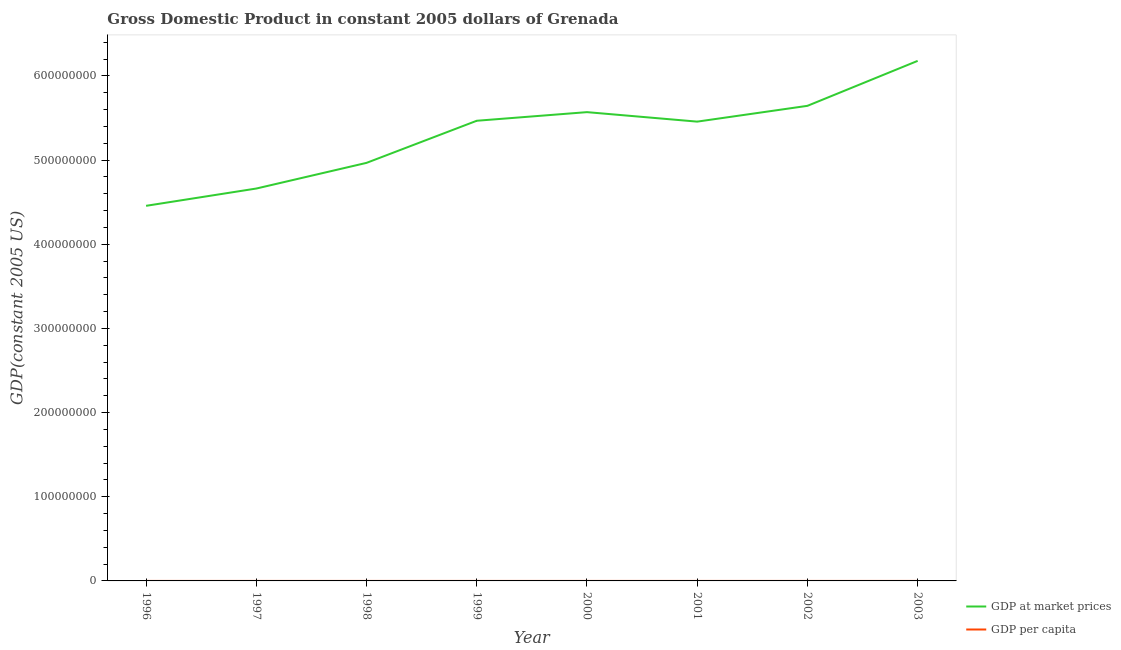What is the gdp per capita in 2000?
Your answer should be compact. 5481.04. Across all years, what is the maximum gdp at market prices?
Make the answer very short. 6.18e+08. Across all years, what is the minimum gdp per capita?
Ensure brevity in your answer.  4421.53. In which year was the gdp per capita minimum?
Keep it short and to the point. 1996. What is the total gdp per capita in the graph?
Ensure brevity in your answer.  4.17e+04. What is the difference between the gdp at market prices in 1998 and that in 1999?
Give a very brief answer. -5.00e+07. What is the difference between the gdp per capita in 2002 and the gdp at market prices in 1996?
Offer a very short reply. -4.46e+08. What is the average gdp at market prices per year?
Your response must be concise. 5.30e+08. In the year 1997, what is the difference between the gdp per capita and gdp at market prices?
Provide a succinct answer. -4.66e+08. What is the ratio of the gdp at market prices in 1996 to that in 2003?
Your response must be concise. 0.72. Is the gdp at market prices in 1998 less than that in 2001?
Your answer should be very brief. Yes. What is the difference between the highest and the second highest gdp at market prices?
Your answer should be very brief. 5.34e+07. What is the difference between the highest and the lowest gdp per capita?
Your answer should be compact. 1614.26. Is the sum of the gdp per capita in 1997 and 2003 greater than the maximum gdp at market prices across all years?
Your response must be concise. No. Does the gdp at market prices monotonically increase over the years?
Offer a very short reply. No. Is the gdp per capita strictly greater than the gdp at market prices over the years?
Offer a very short reply. No. How many lines are there?
Your answer should be very brief. 2. How many years are there in the graph?
Give a very brief answer. 8. Does the graph contain grids?
Provide a succinct answer. No. Where does the legend appear in the graph?
Provide a succinct answer. Bottom right. How many legend labels are there?
Provide a succinct answer. 2. How are the legend labels stacked?
Make the answer very short. Vertical. What is the title of the graph?
Provide a short and direct response. Gross Domestic Product in constant 2005 dollars of Grenada. What is the label or title of the X-axis?
Offer a terse response. Year. What is the label or title of the Y-axis?
Your response must be concise. GDP(constant 2005 US). What is the GDP(constant 2005 US) of GDP at market prices in 1996?
Give a very brief answer. 4.46e+08. What is the GDP(constant 2005 US) of GDP per capita in 1996?
Keep it short and to the point. 4421.53. What is the GDP(constant 2005 US) of GDP at market prices in 1997?
Your answer should be very brief. 4.66e+08. What is the GDP(constant 2005 US) of GDP per capita in 1997?
Your answer should be compact. 4610.26. What is the GDP(constant 2005 US) in GDP at market prices in 1998?
Your response must be concise. 4.97e+08. What is the GDP(constant 2005 US) in GDP per capita in 1998?
Your answer should be compact. 4903.28. What is the GDP(constant 2005 US) of GDP at market prices in 1999?
Give a very brief answer. 5.47e+08. What is the GDP(constant 2005 US) in GDP per capita in 1999?
Your response must be concise. 5389.76. What is the GDP(constant 2005 US) in GDP at market prices in 2000?
Give a very brief answer. 5.57e+08. What is the GDP(constant 2005 US) of GDP per capita in 2000?
Make the answer very short. 5481.04. What is the GDP(constant 2005 US) in GDP at market prices in 2001?
Ensure brevity in your answer.  5.46e+08. What is the GDP(constant 2005 US) in GDP per capita in 2001?
Offer a terse response. 5358.03. What is the GDP(constant 2005 US) in GDP at market prices in 2002?
Provide a succinct answer. 5.64e+08. What is the GDP(constant 2005 US) in GDP per capita in 2002?
Offer a terse response. 5528.58. What is the GDP(constant 2005 US) of GDP at market prices in 2003?
Provide a short and direct response. 6.18e+08. What is the GDP(constant 2005 US) of GDP per capita in 2003?
Your answer should be compact. 6035.78. Across all years, what is the maximum GDP(constant 2005 US) of GDP at market prices?
Provide a succinct answer. 6.18e+08. Across all years, what is the maximum GDP(constant 2005 US) of GDP per capita?
Ensure brevity in your answer.  6035.78. Across all years, what is the minimum GDP(constant 2005 US) of GDP at market prices?
Provide a short and direct response. 4.46e+08. Across all years, what is the minimum GDP(constant 2005 US) of GDP per capita?
Offer a terse response. 4421.53. What is the total GDP(constant 2005 US) in GDP at market prices in the graph?
Give a very brief answer. 4.24e+09. What is the total GDP(constant 2005 US) in GDP per capita in the graph?
Give a very brief answer. 4.17e+04. What is the difference between the GDP(constant 2005 US) of GDP at market prices in 1996 and that in 1997?
Offer a terse response. -2.05e+07. What is the difference between the GDP(constant 2005 US) in GDP per capita in 1996 and that in 1997?
Keep it short and to the point. -188.73. What is the difference between the GDP(constant 2005 US) in GDP at market prices in 1996 and that in 1998?
Offer a terse response. -5.10e+07. What is the difference between the GDP(constant 2005 US) in GDP per capita in 1996 and that in 1998?
Provide a succinct answer. -481.75. What is the difference between the GDP(constant 2005 US) of GDP at market prices in 1996 and that in 1999?
Offer a very short reply. -1.01e+08. What is the difference between the GDP(constant 2005 US) in GDP per capita in 1996 and that in 1999?
Offer a very short reply. -968.24. What is the difference between the GDP(constant 2005 US) of GDP at market prices in 1996 and that in 2000?
Your answer should be compact. -1.11e+08. What is the difference between the GDP(constant 2005 US) in GDP per capita in 1996 and that in 2000?
Make the answer very short. -1059.51. What is the difference between the GDP(constant 2005 US) of GDP at market prices in 1996 and that in 2001?
Your answer should be very brief. -1.00e+08. What is the difference between the GDP(constant 2005 US) of GDP per capita in 1996 and that in 2001?
Your answer should be compact. -936.51. What is the difference between the GDP(constant 2005 US) in GDP at market prices in 1996 and that in 2002?
Offer a very short reply. -1.19e+08. What is the difference between the GDP(constant 2005 US) in GDP per capita in 1996 and that in 2002?
Give a very brief answer. -1107.05. What is the difference between the GDP(constant 2005 US) in GDP at market prices in 1996 and that in 2003?
Provide a short and direct response. -1.72e+08. What is the difference between the GDP(constant 2005 US) of GDP per capita in 1996 and that in 2003?
Make the answer very short. -1614.26. What is the difference between the GDP(constant 2005 US) in GDP at market prices in 1997 and that in 1998?
Give a very brief answer. -3.05e+07. What is the difference between the GDP(constant 2005 US) in GDP per capita in 1997 and that in 1998?
Give a very brief answer. -293.02. What is the difference between the GDP(constant 2005 US) in GDP at market prices in 1997 and that in 1999?
Your response must be concise. -8.05e+07. What is the difference between the GDP(constant 2005 US) in GDP per capita in 1997 and that in 1999?
Offer a terse response. -779.5. What is the difference between the GDP(constant 2005 US) of GDP at market prices in 1997 and that in 2000?
Your answer should be compact. -9.08e+07. What is the difference between the GDP(constant 2005 US) of GDP per capita in 1997 and that in 2000?
Your response must be concise. -870.78. What is the difference between the GDP(constant 2005 US) of GDP at market prices in 1997 and that in 2001?
Ensure brevity in your answer.  -7.95e+07. What is the difference between the GDP(constant 2005 US) in GDP per capita in 1997 and that in 2001?
Your answer should be compact. -747.77. What is the difference between the GDP(constant 2005 US) of GDP at market prices in 1997 and that in 2002?
Ensure brevity in your answer.  -9.83e+07. What is the difference between the GDP(constant 2005 US) of GDP per capita in 1997 and that in 2002?
Make the answer very short. -918.32. What is the difference between the GDP(constant 2005 US) of GDP at market prices in 1997 and that in 2003?
Offer a very short reply. -1.52e+08. What is the difference between the GDP(constant 2005 US) of GDP per capita in 1997 and that in 2003?
Provide a short and direct response. -1425.52. What is the difference between the GDP(constant 2005 US) of GDP at market prices in 1998 and that in 1999?
Your response must be concise. -5.00e+07. What is the difference between the GDP(constant 2005 US) in GDP per capita in 1998 and that in 1999?
Your answer should be very brief. -486.49. What is the difference between the GDP(constant 2005 US) in GDP at market prices in 1998 and that in 2000?
Ensure brevity in your answer.  -6.03e+07. What is the difference between the GDP(constant 2005 US) in GDP per capita in 1998 and that in 2000?
Make the answer very short. -577.76. What is the difference between the GDP(constant 2005 US) of GDP at market prices in 1998 and that in 2001?
Your response must be concise. -4.90e+07. What is the difference between the GDP(constant 2005 US) in GDP per capita in 1998 and that in 2001?
Keep it short and to the point. -454.76. What is the difference between the GDP(constant 2005 US) in GDP at market prices in 1998 and that in 2002?
Offer a very short reply. -6.78e+07. What is the difference between the GDP(constant 2005 US) of GDP per capita in 1998 and that in 2002?
Offer a very short reply. -625.3. What is the difference between the GDP(constant 2005 US) of GDP at market prices in 1998 and that in 2003?
Provide a short and direct response. -1.21e+08. What is the difference between the GDP(constant 2005 US) in GDP per capita in 1998 and that in 2003?
Ensure brevity in your answer.  -1132.51. What is the difference between the GDP(constant 2005 US) of GDP at market prices in 1999 and that in 2000?
Your answer should be compact. -1.02e+07. What is the difference between the GDP(constant 2005 US) of GDP per capita in 1999 and that in 2000?
Your answer should be very brief. -91.27. What is the difference between the GDP(constant 2005 US) of GDP at market prices in 1999 and that in 2001?
Give a very brief answer. 1.03e+06. What is the difference between the GDP(constant 2005 US) in GDP per capita in 1999 and that in 2001?
Make the answer very short. 31.73. What is the difference between the GDP(constant 2005 US) in GDP at market prices in 1999 and that in 2002?
Your response must be concise. -1.77e+07. What is the difference between the GDP(constant 2005 US) of GDP per capita in 1999 and that in 2002?
Provide a short and direct response. -138.82. What is the difference between the GDP(constant 2005 US) in GDP at market prices in 1999 and that in 2003?
Keep it short and to the point. -7.11e+07. What is the difference between the GDP(constant 2005 US) in GDP per capita in 1999 and that in 2003?
Your answer should be very brief. -646.02. What is the difference between the GDP(constant 2005 US) of GDP at market prices in 2000 and that in 2001?
Your response must be concise. 1.13e+07. What is the difference between the GDP(constant 2005 US) in GDP per capita in 2000 and that in 2001?
Your answer should be compact. 123. What is the difference between the GDP(constant 2005 US) of GDP at market prices in 2000 and that in 2002?
Ensure brevity in your answer.  -7.49e+06. What is the difference between the GDP(constant 2005 US) in GDP per capita in 2000 and that in 2002?
Keep it short and to the point. -47.54. What is the difference between the GDP(constant 2005 US) in GDP at market prices in 2000 and that in 2003?
Provide a short and direct response. -6.09e+07. What is the difference between the GDP(constant 2005 US) of GDP per capita in 2000 and that in 2003?
Offer a very short reply. -554.75. What is the difference between the GDP(constant 2005 US) of GDP at market prices in 2001 and that in 2002?
Ensure brevity in your answer.  -1.88e+07. What is the difference between the GDP(constant 2005 US) in GDP per capita in 2001 and that in 2002?
Give a very brief answer. -170.55. What is the difference between the GDP(constant 2005 US) of GDP at market prices in 2001 and that in 2003?
Provide a succinct answer. -7.22e+07. What is the difference between the GDP(constant 2005 US) of GDP per capita in 2001 and that in 2003?
Provide a short and direct response. -677.75. What is the difference between the GDP(constant 2005 US) of GDP at market prices in 2002 and that in 2003?
Your answer should be very brief. -5.34e+07. What is the difference between the GDP(constant 2005 US) of GDP per capita in 2002 and that in 2003?
Provide a succinct answer. -507.2. What is the difference between the GDP(constant 2005 US) in GDP at market prices in 1996 and the GDP(constant 2005 US) in GDP per capita in 1997?
Your answer should be very brief. 4.46e+08. What is the difference between the GDP(constant 2005 US) of GDP at market prices in 1996 and the GDP(constant 2005 US) of GDP per capita in 1998?
Ensure brevity in your answer.  4.46e+08. What is the difference between the GDP(constant 2005 US) of GDP at market prices in 1996 and the GDP(constant 2005 US) of GDP per capita in 1999?
Give a very brief answer. 4.46e+08. What is the difference between the GDP(constant 2005 US) in GDP at market prices in 1996 and the GDP(constant 2005 US) in GDP per capita in 2000?
Give a very brief answer. 4.46e+08. What is the difference between the GDP(constant 2005 US) in GDP at market prices in 1996 and the GDP(constant 2005 US) in GDP per capita in 2001?
Your answer should be compact. 4.46e+08. What is the difference between the GDP(constant 2005 US) of GDP at market prices in 1996 and the GDP(constant 2005 US) of GDP per capita in 2002?
Provide a short and direct response. 4.46e+08. What is the difference between the GDP(constant 2005 US) in GDP at market prices in 1996 and the GDP(constant 2005 US) in GDP per capita in 2003?
Your response must be concise. 4.46e+08. What is the difference between the GDP(constant 2005 US) in GDP at market prices in 1997 and the GDP(constant 2005 US) in GDP per capita in 1998?
Ensure brevity in your answer.  4.66e+08. What is the difference between the GDP(constant 2005 US) in GDP at market prices in 1997 and the GDP(constant 2005 US) in GDP per capita in 1999?
Offer a terse response. 4.66e+08. What is the difference between the GDP(constant 2005 US) in GDP at market prices in 1997 and the GDP(constant 2005 US) in GDP per capita in 2000?
Give a very brief answer. 4.66e+08. What is the difference between the GDP(constant 2005 US) in GDP at market prices in 1997 and the GDP(constant 2005 US) in GDP per capita in 2001?
Make the answer very short. 4.66e+08. What is the difference between the GDP(constant 2005 US) in GDP at market prices in 1997 and the GDP(constant 2005 US) in GDP per capita in 2002?
Your answer should be very brief. 4.66e+08. What is the difference between the GDP(constant 2005 US) of GDP at market prices in 1997 and the GDP(constant 2005 US) of GDP per capita in 2003?
Give a very brief answer. 4.66e+08. What is the difference between the GDP(constant 2005 US) in GDP at market prices in 1998 and the GDP(constant 2005 US) in GDP per capita in 1999?
Provide a succinct answer. 4.97e+08. What is the difference between the GDP(constant 2005 US) of GDP at market prices in 1998 and the GDP(constant 2005 US) of GDP per capita in 2000?
Your answer should be very brief. 4.97e+08. What is the difference between the GDP(constant 2005 US) of GDP at market prices in 1998 and the GDP(constant 2005 US) of GDP per capita in 2001?
Provide a succinct answer. 4.97e+08. What is the difference between the GDP(constant 2005 US) in GDP at market prices in 1998 and the GDP(constant 2005 US) in GDP per capita in 2002?
Your response must be concise. 4.97e+08. What is the difference between the GDP(constant 2005 US) of GDP at market prices in 1998 and the GDP(constant 2005 US) of GDP per capita in 2003?
Offer a very short reply. 4.97e+08. What is the difference between the GDP(constant 2005 US) of GDP at market prices in 1999 and the GDP(constant 2005 US) of GDP per capita in 2000?
Give a very brief answer. 5.47e+08. What is the difference between the GDP(constant 2005 US) of GDP at market prices in 1999 and the GDP(constant 2005 US) of GDP per capita in 2001?
Ensure brevity in your answer.  5.47e+08. What is the difference between the GDP(constant 2005 US) of GDP at market prices in 1999 and the GDP(constant 2005 US) of GDP per capita in 2002?
Provide a succinct answer. 5.47e+08. What is the difference between the GDP(constant 2005 US) of GDP at market prices in 1999 and the GDP(constant 2005 US) of GDP per capita in 2003?
Your response must be concise. 5.47e+08. What is the difference between the GDP(constant 2005 US) in GDP at market prices in 2000 and the GDP(constant 2005 US) in GDP per capita in 2001?
Your response must be concise. 5.57e+08. What is the difference between the GDP(constant 2005 US) of GDP at market prices in 2000 and the GDP(constant 2005 US) of GDP per capita in 2002?
Give a very brief answer. 5.57e+08. What is the difference between the GDP(constant 2005 US) in GDP at market prices in 2000 and the GDP(constant 2005 US) in GDP per capita in 2003?
Provide a short and direct response. 5.57e+08. What is the difference between the GDP(constant 2005 US) in GDP at market prices in 2001 and the GDP(constant 2005 US) in GDP per capita in 2002?
Provide a short and direct response. 5.46e+08. What is the difference between the GDP(constant 2005 US) in GDP at market prices in 2001 and the GDP(constant 2005 US) in GDP per capita in 2003?
Offer a very short reply. 5.46e+08. What is the difference between the GDP(constant 2005 US) of GDP at market prices in 2002 and the GDP(constant 2005 US) of GDP per capita in 2003?
Ensure brevity in your answer.  5.64e+08. What is the average GDP(constant 2005 US) of GDP at market prices per year?
Your answer should be very brief. 5.30e+08. What is the average GDP(constant 2005 US) in GDP per capita per year?
Your answer should be very brief. 5216.03. In the year 1996, what is the difference between the GDP(constant 2005 US) in GDP at market prices and GDP(constant 2005 US) in GDP per capita?
Your response must be concise. 4.46e+08. In the year 1997, what is the difference between the GDP(constant 2005 US) of GDP at market prices and GDP(constant 2005 US) of GDP per capita?
Make the answer very short. 4.66e+08. In the year 1998, what is the difference between the GDP(constant 2005 US) in GDP at market prices and GDP(constant 2005 US) in GDP per capita?
Provide a short and direct response. 4.97e+08. In the year 1999, what is the difference between the GDP(constant 2005 US) of GDP at market prices and GDP(constant 2005 US) of GDP per capita?
Your answer should be very brief. 5.47e+08. In the year 2000, what is the difference between the GDP(constant 2005 US) of GDP at market prices and GDP(constant 2005 US) of GDP per capita?
Your response must be concise. 5.57e+08. In the year 2001, what is the difference between the GDP(constant 2005 US) in GDP at market prices and GDP(constant 2005 US) in GDP per capita?
Your response must be concise. 5.46e+08. In the year 2002, what is the difference between the GDP(constant 2005 US) of GDP at market prices and GDP(constant 2005 US) of GDP per capita?
Your answer should be compact. 5.64e+08. In the year 2003, what is the difference between the GDP(constant 2005 US) of GDP at market prices and GDP(constant 2005 US) of GDP per capita?
Your response must be concise. 6.18e+08. What is the ratio of the GDP(constant 2005 US) of GDP at market prices in 1996 to that in 1997?
Offer a terse response. 0.96. What is the ratio of the GDP(constant 2005 US) in GDP per capita in 1996 to that in 1997?
Provide a succinct answer. 0.96. What is the ratio of the GDP(constant 2005 US) of GDP at market prices in 1996 to that in 1998?
Your answer should be compact. 0.9. What is the ratio of the GDP(constant 2005 US) of GDP per capita in 1996 to that in 1998?
Keep it short and to the point. 0.9. What is the ratio of the GDP(constant 2005 US) of GDP at market prices in 1996 to that in 1999?
Your answer should be very brief. 0.82. What is the ratio of the GDP(constant 2005 US) in GDP per capita in 1996 to that in 1999?
Offer a very short reply. 0.82. What is the ratio of the GDP(constant 2005 US) of GDP at market prices in 1996 to that in 2000?
Provide a short and direct response. 0.8. What is the ratio of the GDP(constant 2005 US) in GDP per capita in 1996 to that in 2000?
Provide a short and direct response. 0.81. What is the ratio of the GDP(constant 2005 US) in GDP at market prices in 1996 to that in 2001?
Provide a succinct answer. 0.82. What is the ratio of the GDP(constant 2005 US) of GDP per capita in 1996 to that in 2001?
Your response must be concise. 0.83. What is the ratio of the GDP(constant 2005 US) in GDP at market prices in 1996 to that in 2002?
Your answer should be very brief. 0.79. What is the ratio of the GDP(constant 2005 US) in GDP per capita in 1996 to that in 2002?
Give a very brief answer. 0.8. What is the ratio of the GDP(constant 2005 US) of GDP at market prices in 1996 to that in 2003?
Keep it short and to the point. 0.72. What is the ratio of the GDP(constant 2005 US) of GDP per capita in 1996 to that in 2003?
Offer a very short reply. 0.73. What is the ratio of the GDP(constant 2005 US) in GDP at market prices in 1997 to that in 1998?
Give a very brief answer. 0.94. What is the ratio of the GDP(constant 2005 US) in GDP per capita in 1997 to that in 1998?
Make the answer very short. 0.94. What is the ratio of the GDP(constant 2005 US) in GDP at market prices in 1997 to that in 1999?
Your response must be concise. 0.85. What is the ratio of the GDP(constant 2005 US) in GDP per capita in 1997 to that in 1999?
Offer a terse response. 0.86. What is the ratio of the GDP(constant 2005 US) of GDP at market prices in 1997 to that in 2000?
Your response must be concise. 0.84. What is the ratio of the GDP(constant 2005 US) of GDP per capita in 1997 to that in 2000?
Provide a short and direct response. 0.84. What is the ratio of the GDP(constant 2005 US) of GDP at market prices in 1997 to that in 2001?
Your answer should be very brief. 0.85. What is the ratio of the GDP(constant 2005 US) in GDP per capita in 1997 to that in 2001?
Ensure brevity in your answer.  0.86. What is the ratio of the GDP(constant 2005 US) in GDP at market prices in 1997 to that in 2002?
Ensure brevity in your answer.  0.83. What is the ratio of the GDP(constant 2005 US) of GDP per capita in 1997 to that in 2002?
Provide a succinct answer. 0.83. What is the ratio of the GDP(constant 2005 US) of GDP at market prices in 1997 to that in 2003?
Offer a terse response. 0.75. What is the ratio of the GDP(constant 2005 US) in GDP per capita in 1997 to that in 2003?
Keep it short and to the point. 0.76. What is the ratio of the GDP(constant 2005 US) in GDP at market prices in 1998 to that in 1999?
Offer a very short reply. 0.91. What is the ratio of the GDP(constant 2005 US) of GDP per capita in 1998 to that in 1999?
Offer a very short reply. 0.91. What is the ratio of the GDP(constant 2005 US) of GDP at market prices in 1998 to that in 2000?
Provide a succinct answer. 0.89. What is the ratio of the GDP(constant 2005 US) in GDP per capita in 1998 to that in 2000?
Ensure brevity in your answer.  0.89. What is the ratio of the GDP(constant 2005 US) of GDP at market prices in 1998 to that in 2001?
Provide a short and direct response. 0.91. What is the ratio of the GDP(constant 2005 US) in GDP per capita in 1998 to that in 2001?
Give a very brief answer. 0.92. What is the ratio of the GDP(constant 2005 US) in GDP per capita in 1998 to that in 2002?
Your answer should be compact. 0.89. What is the ratio of the GDP(constant 2005 US) of GDP at market prices in 1998 to that in 2003?
Your answer should be very brief. 0.8. What is the ratio of the GDP(constant 2005 US) in GDP per capita in 1998 to that in 2003?
Your response must be concise. 0.81. What is the ratio of the GDP(constant 2005 US) in GDP at market prices in 1999 to that in 2000?
Your answer should be compact. 0.98. What is the ratio of the GDP(constant 2005 US) in GDP per capita in 1999 to that in 2000?
Make the answer very short. 0.98. What is the ratio of the GDP(constant 2005 US) in GDP per capita in 1999 to that in 2001?
Your answer should be very brief. 1.01. What is the ratio of the GDP(constant 2005 US) in GDP at market prices in 1999 to that in 2002?
Keep it short and to the point. 0.97. What is the ratio of the GDP(constant 2005 US) in GDP per capita in 1999 to that in 2002?
Give a very brief answer. 0.97. What is the ratio of the GDP(constant 2005 US) of GDP at market prices in 1999 to that in 2003?
Make the answer very short. 0.88. What is the ratio of the GDP(constant 2005 US) of GDP per capita in 1999 to that in 2003?
Your answer should be very brief. 0.89. What is the ratio of the GDP(constant 2005 US) in GDP at market prices in 2000 to that in 2001?
Ensure brevity in your answer.  1.02. What is the ratio of the GDP(constant 2005 US) in GDP at market prices in 2000 to that in 2002?
Your answer should be very brief. 0.99. What is the ratio of the GDP(constant 2005 US) in GDP at market prices in 2000 to that in 2003?
Give a very brief answer. 0.9. What is the ratio of the GDP(constant 2005 US) in GDP per capita in 2000 to that in 2003?
Ensure brevity in your answer.  0.91. What is the ratio of the GDP(constant 2005 US) in GDP at market prices in 2001 to that in 2002?
Give a very brief answer. 0.97. What is the ratio of the GDP(constant 2005 US) of GDP per capita in 2001 to that in 2002?
Keep it short and to the point. 0.97. What is the ratio of the GDP(constant 2005 US) of GDP at market prices in 2001 to that in 2003?
Your response must be concise. 0.88. What is the ratio of the GDP(constant 2005 US) in GDP per capita in 2001 to that in 2003?
Offer a very short reply. 0.89. What is the ratio of the GDP(constant 2005 US) in GDP at market prices in 2002 to that in 2003?
Ensure brevity in your answer.  0.91. What is the ratio of the GDP(constant 2005 US) of GDP per capita in 2002 to that in 2003?
Keep it short and to the point. 0.92. What is the difference between the highest and the second highest GDP(constant 2005 US) in GDP at market prices?
Make the answer very short. 5.34e+07. What is the difference between the highest and the second highest GDP(constant 2005 US) of GDP per capita?
Your response must be concise. 507.2. What is the difference between the highest and the lowest GDP(constant 2005 US) in GDP at market prices?
Ensure brevity in your answer.  1.72e+08. What is the difference between the highest and the lowest GDP(constant 2005 US) in GDP per capita?
Your answer should be very brief. 1614.26. 